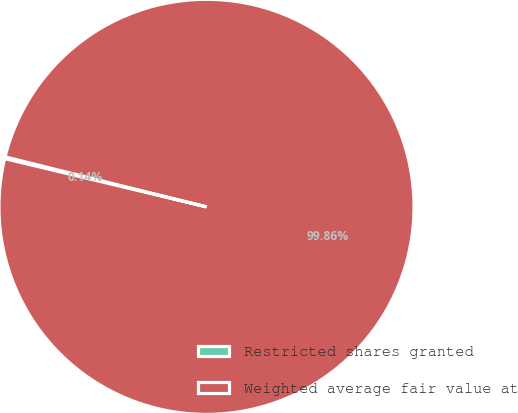<chart> <loc_0><loc_0><loc_500><loc_500><pie_chart><fcel>Restricted shares granted<fcel>Weighted average fair value at<nl><fcel>0.14%<fcel>99.86%<nl></chart> 